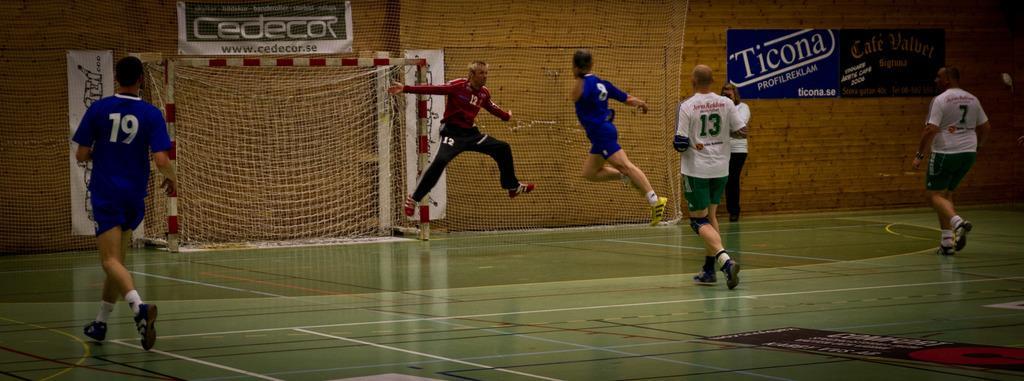Please provide a concise description of this image. In the foreground of this image, on a football floor, there are three men running. In the background, there are two men jumping in the air and a person standing near a wall on which few posters are present and there is also a goal net in the background. 